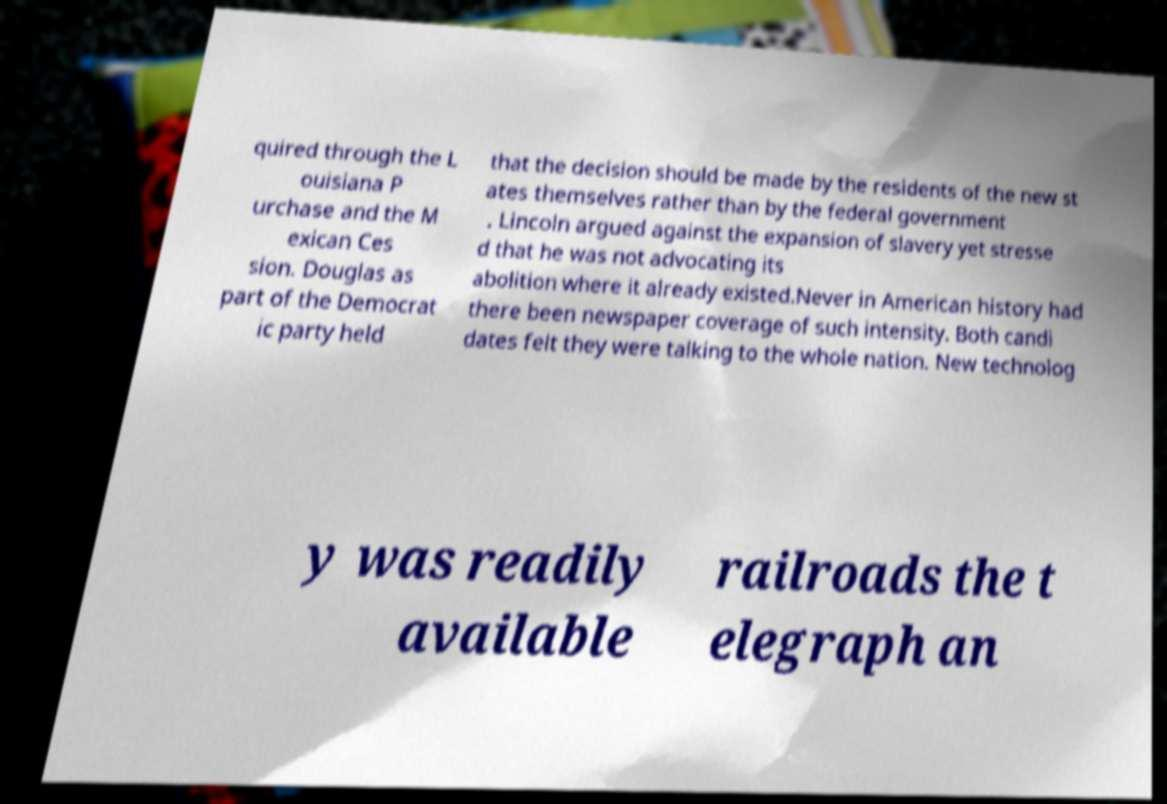Please read and relay the text visible in this image. What does it say? quired through the L ouisiana P urchase and the M exican Ces sion. Douglas as part of the Democrat ic party held that the decision should be made by the residents of the new st ates themselves rather than by the federal government . Lincoln argued against the expansion of slavery yet stresse d that he was not advocating its abolition where it already existed.Never in American history had there been newspaper coverage of such intensity. Both candi dates felt they were talking to the whole nation. New technolog y was readily available railroads the t elegraph an 